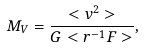<formula> <loc_0><loc_0><loc_500><loc_500>M _ { V } = \frac { < v ^ { 2 } > } { G < r ^ { - 1 } F > } ,</formula> 